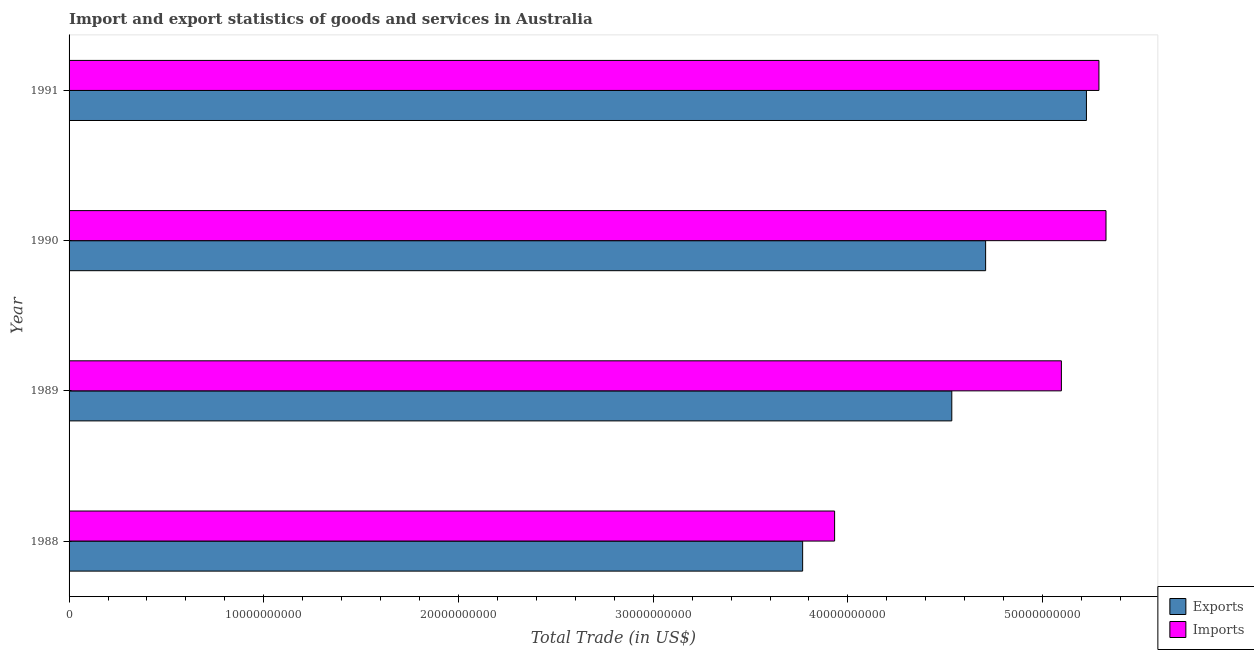How many groups of bars are there?
Offer a terse response. 4. Are the number of bars per tick equal to the number of legend labels?
Ensure brevity in your answer.  Yes. What is the label of the 4th group of bars from the top?
Your answer should be compact. 1988. What is the imports of goods and services in 1991?
Ensure brevity in your answer.  5.29e+1. Across all years, what is the maximum export of goods and services?
Your response must be concise. 5.22e+1. Across all years, what is the minimum export of goods and services?
Your answer should be compact. 3.77e+1. In which year was the imports of goods and services maximum?
Your answer should be very brief. 1990. In which year was the imports of goods and services minimum?
Ensure brevity in your answer.  1988. What is the total export of goods and services in the graph?
Keep it short and to the point. 1.82e+11. What is the difference between the export of goods and services in 1988 and that in 1990?
Provide a succinct answer. -9.40e+09. What is the difference between the export of goods and services in 1991 and the imports of goods and services in 1989?
Your response must be concise. 1.29e+09. What is the average export of goods and services per year?
Keep it short and to the point. 4.56e+1. In the year 1988, what is the difference between the imports of goods and services and export of goods and services?
Your response must be concise. 1.64e+09. In how many years, is the export of goods and services greater than 16000000000 US$?
Offer a terse response. 4. What is the ratio of the export of goods and services in 1988 to that in 1991?
Provide a short and direct response. 0.72. Is the difference between the export of goods and services in 1988 and 1990 greater than the difference between the imports of goods and services in 1988 and 1990?
Offer a terse response. Yes. What is the difference between the highest and the second highest imports of goods and services?
Make the answer very short. 3.63e+08. What is the difference between the highest and the lowest imports of goods and services?
Your answer should be very brief. 1.39e+1. What does the 2nd bar from the top in 1991 represents?
Your answer should be compact. Exports. What does the 2nd bar from the bottom in 1991 represents?
Offer a very short reply. Imports. How many bars are there?
Your answer should be compact. 8. How many years are there in the graph?
Your answer should be compact. 4. What is the difference between two consecutive major ticks on the X-axis?
Your answer should be very brief. 1.00e+1. Does the graph contain grids?
Offer a very short reply. No. Where does the legend appear in the graph?
Ensure brevity in your answer.  Bottom right. How are the legend labels stacked?
Make the answer very short. Vertical. What is the title of the graph?
Your response must be concise. Import and export statistics of goods and services in Australia. Does "Transport services" appear as one of the legend labels in the graph?
Your response must be concise. No. What is the label or title of the X-axis?
Offer a very short reply. Total Trade (in US$). What is the label or title of the Y-axis?
Keep it short and to the point. Year. What is the Total Trade (in US$) in Exports in 1988?
Provide a short and direct response. 3.77e+1. What is the Total Trade (in US$) in Imports in 1988?
Make the answer very short. 3.93e+1. What is the Total Trade (in US$) in Exports in 1989?
Provide a short and direct response. 4.53e+1. What is the Total Trade (in US$) in Imports in 1989?
Provide a short and direct response. 5.10e+1. What is the Total Trade (in US$) of Exports in 1990?
Give a very brief answer. 4.71e+1. What is the Total Trade (in US$) in Imports in 1990?
Your answer should be very brief. 5.33e+1. What is the Total Trade (in US$) in Exports in 1991?
Your answer should be very brief. 5.22e+1. What is the Total Trade (in US$) of Imports in 1991?
Ensure brevity in your answer.  5.29e+1. Across all years, what is the maximum Total Trade (in US$) of Exports?
Keep it short and to the point. 5.22e+1. Across all years, what is the maximum Total Trade (in US$) of Imports?
Provide a succinct answer. 5.33e+1. Across all years, what is the minimum Total Trade (in US$) of Exports?
Provide a short and direct response. 3.77e+1. Across all years, what is the minimum Total Trade (in US$) of Imports?
Give a very brief answer. 3.93e+1. What is the total Total Trade (in US$) of Exports in the graph?
Give a very brief answer. 1.82e+11. What is the total Total Trade (in US$) in Imports in the graph?
Keep it short and to the point. 1.96e+11. What is the difference between the Total Trade (in US$) in Exports in 1988 and that in 1989?
Provide a short and direct response. -7.66e+09. What is the difference between the Total Trade (in US$) of Imports in 1988 and that in 1989?
Your answer should be compact. -1.16e+1. What is the difference between the Total Trade (in US$) in Exports in 1988 and that in 1990?
Provide a short and direct response. -9.40e+09. What is the difference between the Total Trade (in US$) in Imports in 1988 and that in 1990?
Your answer should be very brief. -1.39e+1. What is the difference between the Total Trade (in US$) of Exports in 1988 and that in 1991?
Offer a very short reply. -1.46e+1. What is the difference between the Total Trade (in US$) in Imports in 1988 and that in 1991?
Offer a terse response. -1.36e+1. What is the difference between the Total Trade (in US$) in Exports in 1989 and that in 1990?
Provide a succinct answer. -1.74e+09. What is the difference between the Total Trade (in US$) in Imports in 1989 and that in 1990?
Keep it short and to the point. -2.29e+09. What is the difference between the Total Trade (in US$) in Exports in 1989 and that in 1991?
Make the answer very short. -6.92e+09. What is the difference between the Total Trade (in US$) of Imports in 1989 and that in 1991?
Keep it short and to the point. -1.93e+09. What is the difference between the Total Trade (in US$) in Exports in 1990 and that in 1991?
Offer a very short reply. -5.18e+09. What is the difference between the Total Trade (in US$) of Imports in 1990 and that in 1991?
Your answer should be compact. 3.63e+08. What is the difference between the Total Trade (in US$) of Exports in 1988 and the Total Trade (in US$) of Imports in 1989?
Offer a very short reply. -1.33e+1. What is the difference between the Total Trade (in US$) in Exports in 1988 and the Total Trade (in US$) in Imports in 1990?
Provide a succinct answer. -1.56e+1. What is the difference between the Total Trade (in US$) of Exports in 1988 and the Total Trade (in US$) of Imports in 1991?
Provide a short and direct response. -1.52e+1. What is the difference between the Total Trade (in US$) in Exports in 1989 and the Total Trade (in US$) in Imports in 1990?
Your answer should be very brief. -7.92e+09. What is the difference between the Total Trade (in US$) of Exports in 1989 and the Total Trade (in US$) of Imports in 1991?
Your answer should be very brief. -7.56e+09. What is the difference between the Total Trade (in US$) in Exports in 1990 and the Total Trade (in US$) in Imports in 1991?
Offer a very short reply. -5.82e+09. What is the average Total Trade (in US$) of Exports per year?
Provide a short and direct response. 4.56e+1. What is the average Total Trade (in US$) in Imports per year?
Your answer should be compact. 4.91e+1. In the year 1988, what is the difference between the Total Trade (in US$) of Exports and Total Trade (in US$) of Imports?
Provide a succinct answer. -1.64e+09. In the year 1989, what is the difference between the Total Trade (in US$) in Exports and Total Trade (in US$) in Imports?
Make the answer very short. -5.63e+09. In the year 1990, what is the difference between the Total Trade (in US$) of Exports and Total Trade (in US$) of Imports?
Offer a terse response. -6.18e+09. In the year 1991, what is the difference between the Total Trade (in US$) of Exports and Total Trade (in US$) of Imports?
Your response must be concise. -6.42e+08. What is the ratio of the Total Trade (in US$) of Exports in 1988 to that in 1989?
Your answer should be compact. 0.83. What is the ratio of the Total Trade (in US$) in Imports in 1988 to that in 1989?
Offer a very short reply. 0.77. What is the ratio of the Total Trade (in US$) of Exports in 1988 to that in 1990?
Ensure brevity in your answer.  0.8. What is the ratio of the Total Trade (in US$) in Imports in 1988 to that in 1990?
Your response must be concise. 0.74. What is the ratio of the Total Trade (in US$) of Exports in 1988 to that in 1991?
Make the answer very short. 0.72. What is the ratio of the Total Trade (in US$) in Imports in 1988 to that in 1991?
Provide a succinct answer. 0.74. What is the ratio of the Total Trade (in US$) of Exports in 1989 to that in 1990?
Give a very brief answer. 0.96. What is the ratio of the Total Trade (in US$) in Imports in 1989 to that in 1990?
Give a very brief answer. 0.96. What is the ratio of the Total Trade (in US$) of Exports in 1989 to that in 1991?
Make the answer very short. 0.87. What is the ratio of the Total Trade (in US$) in Imports in 1989 to that in 1991?
Offer a terse response. 0.96. What is the ratio of the Total Trade (in US$) in Exports in 1990 to that in 1991?
Provide a short and direct response. 0.9. What is the difference between the highest and the second highest Total Trade (in US$) of Exports?
Offer a very short reply. 5.18e+09. What is the difference between the highest and the second highest Total Trade (in US$) in Imports?
Ensure brevity in your answer.  3.63e+08. What is the difference between the highest and the lowest Total Trade (in US$) of Exports?
Provide a short and direct response. 1.46e+1. What is the difference between the highest and the lowest Total Trade (in US$) of Imports?
Offer a terse response. 1.39e+1. 